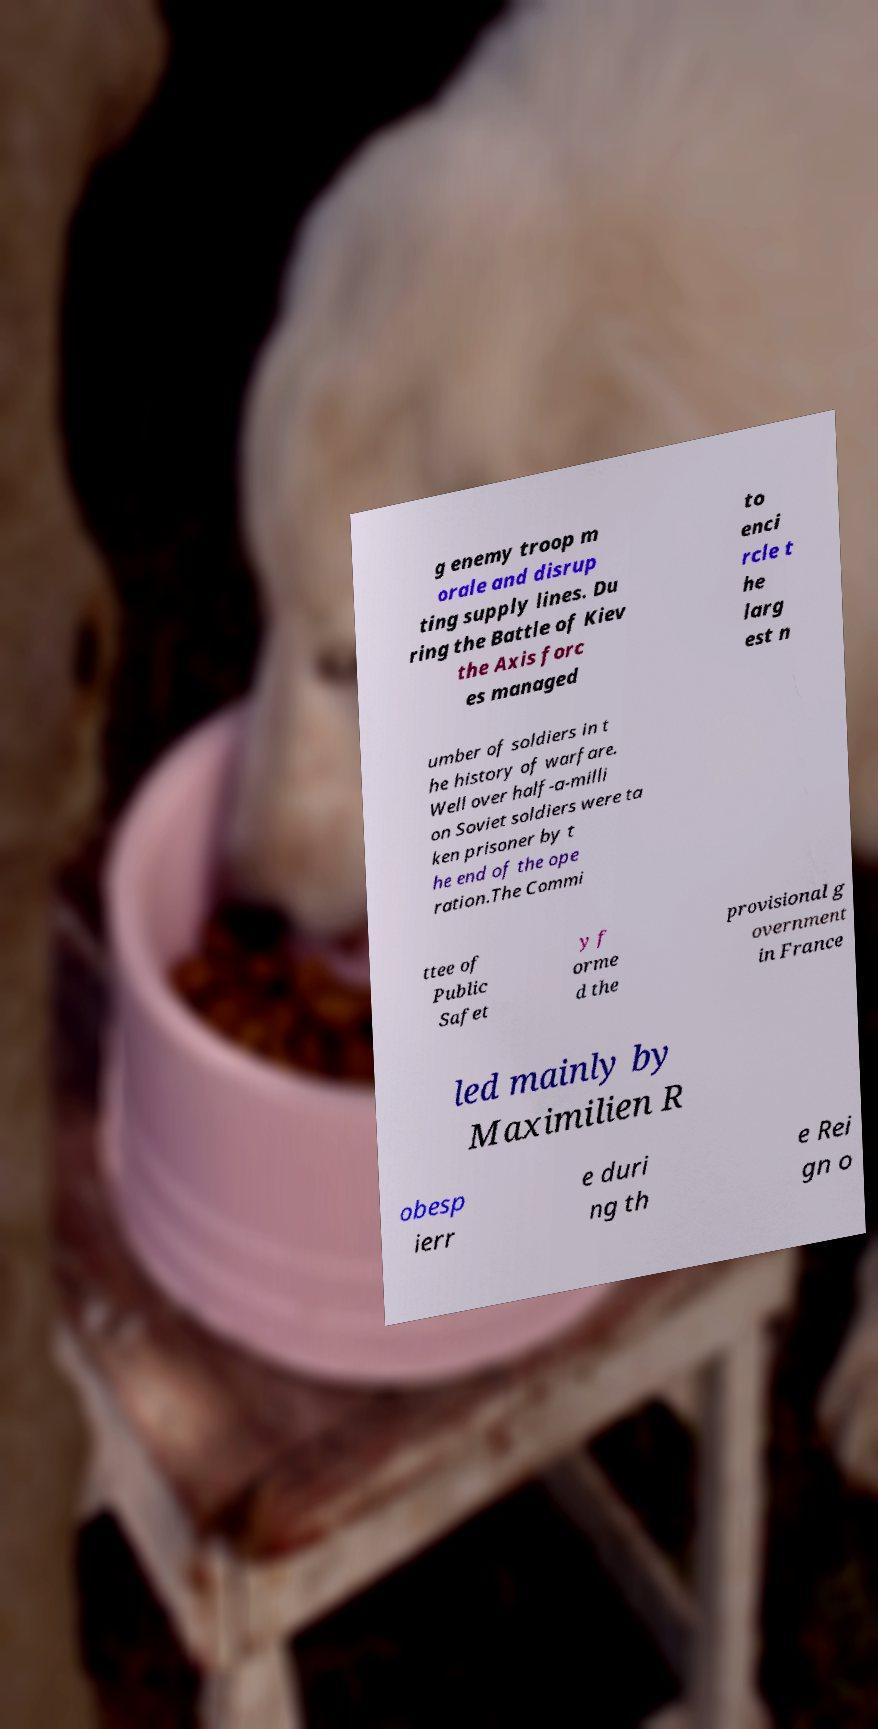Can you accurately transcribe the text from the provided image for me? g enemy troop m orale and disrup ting supply lines. Du ring the Battle of Kiev the Axis forc es managed to enci rcle t he larg est n umber of soldiers in t he history of warfare. Well over half-a-milli on Soviet soldiers were ta ken prisoner by t he end of the ope ration.The Commi ttee of Public Safet y f orme d the provisional g overnment in France led mainly by Maximilien R obesp ierr e duri ng th e Rei gn o 